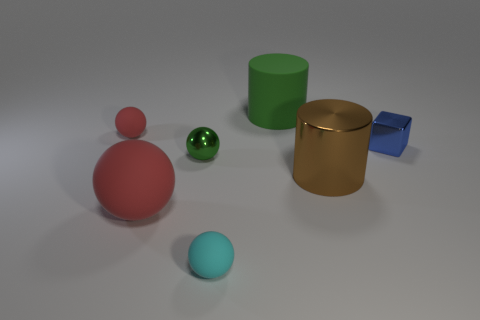What number of metal things have the same color as the large rubber sphere?
Make the answer very short. 0. There is a thing right of the large metal cylinder right of the small matte object in front of the blue object; what is its color?
Your answer should be very brief. Blue. Is the material of the tiny red sphere the same as the large ball?
Ensure brevity in your answer.  Yes. Is the brown metallic thing the same shape as the green matte thing?
Keep it short and to the point. Yes. Is the number of red spheres that are in front of the cyan matte thing the same as the number of big green rubber things that are on the right side of the large green matte object?
Offer a very short reply. Yes. There is a large cylinder that is made of the same material as the large ball; what is its color?
Ensure brevity in your answer.  Green. What number of purple objects have the same material as the cyan object?
Offer a very short reply. 0. Does the tiny thing behind the blue object have the same color as the large matte cylinder?
Offer a very short reply. No. How many other brown objects are the same shape as the large metal object?
Ensure brevity in your answer.  0. Are there the same number of small cyan rubber things behind the tiny cyan thing and big red matte things?
Keep it short and to the point. No. 